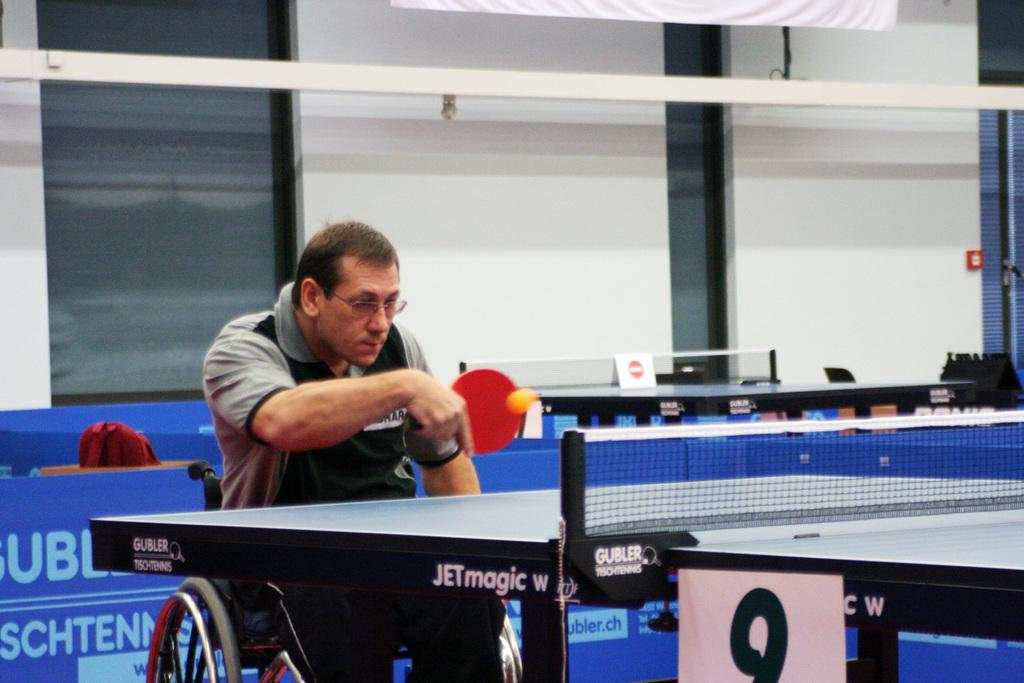What is the man in the image doing? The man is sitting in a wheelchair and holding a bat in front of a table. What can be seen in the background of the image? There are windows and other tables visible in the background of the image. What type of icicle is hanging from the man's wheelchair in the image? There is no icicle present in the image; it is an indoor scene with no ice or cold weather elements. 